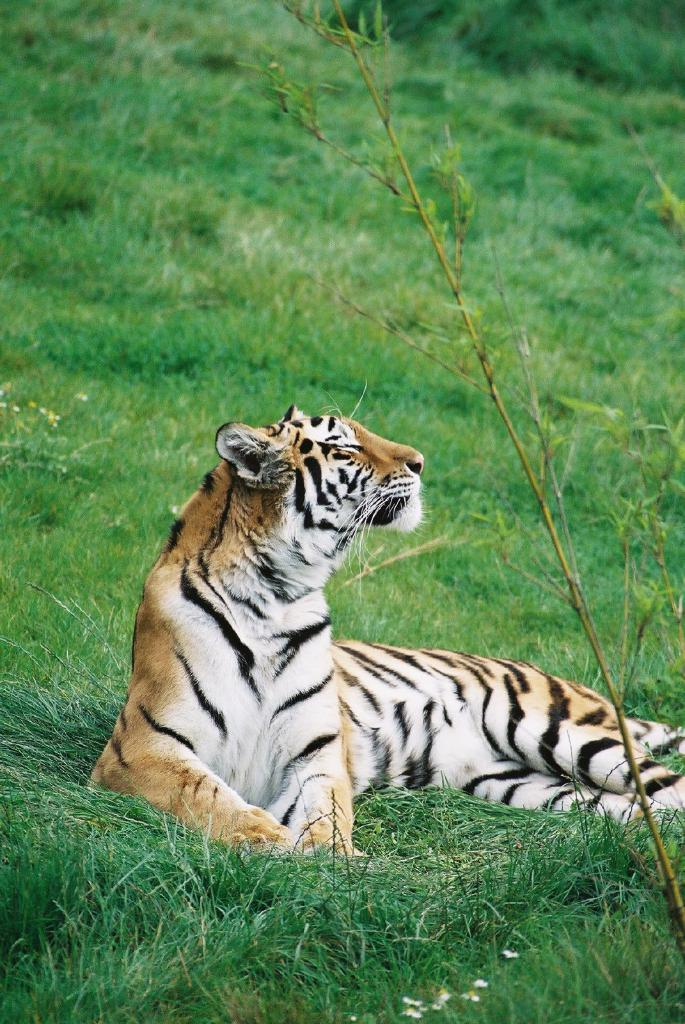What is the main subject in the center of the image? There is a tiger in the center of the image. What type of natural environment is visible at the bottom of the image? There is grass at the bottom of the image. Where is the toothbrush located in the image? There is no toothbrush present in the image. What type of animal is flying in the image? There is no animal flying in the image. What type of bag is visible in the image? There is no bag present in the image. 